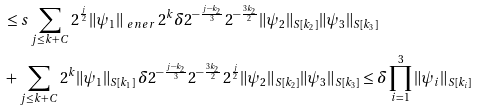<formula> <loc_0><loc_0><loc_500><loc_500>& \leq s \sum _ { j \leq k + C } 2 ^ { \frac { j } { 2 } } \| \psi _ { 1 } \| _ { \ e n e r } \, 2 ^ { k } \delta 2 ^ { - \frac { j - k _ { 2 } } { 3 } } 2 ^ { - \frac { 3 k _ { 2 } } { 2 } } \| \psi _ { 2 } \| _ { S [ k _ { 2 } ] } \| \psi _ { 3 } \| _ { S [ k _ { 3 } ] } \\ & + \sum _ { j \leq k + C } 2 ^ { k } \| \psi _ { 1 } \| _ { S [ k _ { 1 } ] } \, \delta 2 ^ { - \frac { j - k _ { 2 } } { 3 } } 2 ^ { - \frac { 3 k _ { 2 } } { 2 } } 2 ^ { \frac { j } { 2 } } \| \psi _ { 2 } \| _ { S [ k _ { 2 } ] } \| \psi _ { 3 } \| _ { S [ k _ { 3 } ] } \leq \delta \prod _ { i = 1 } ^ { 3 } \| \psi _ { i } \| _ { S [ k _ { i } ] }</formula> 